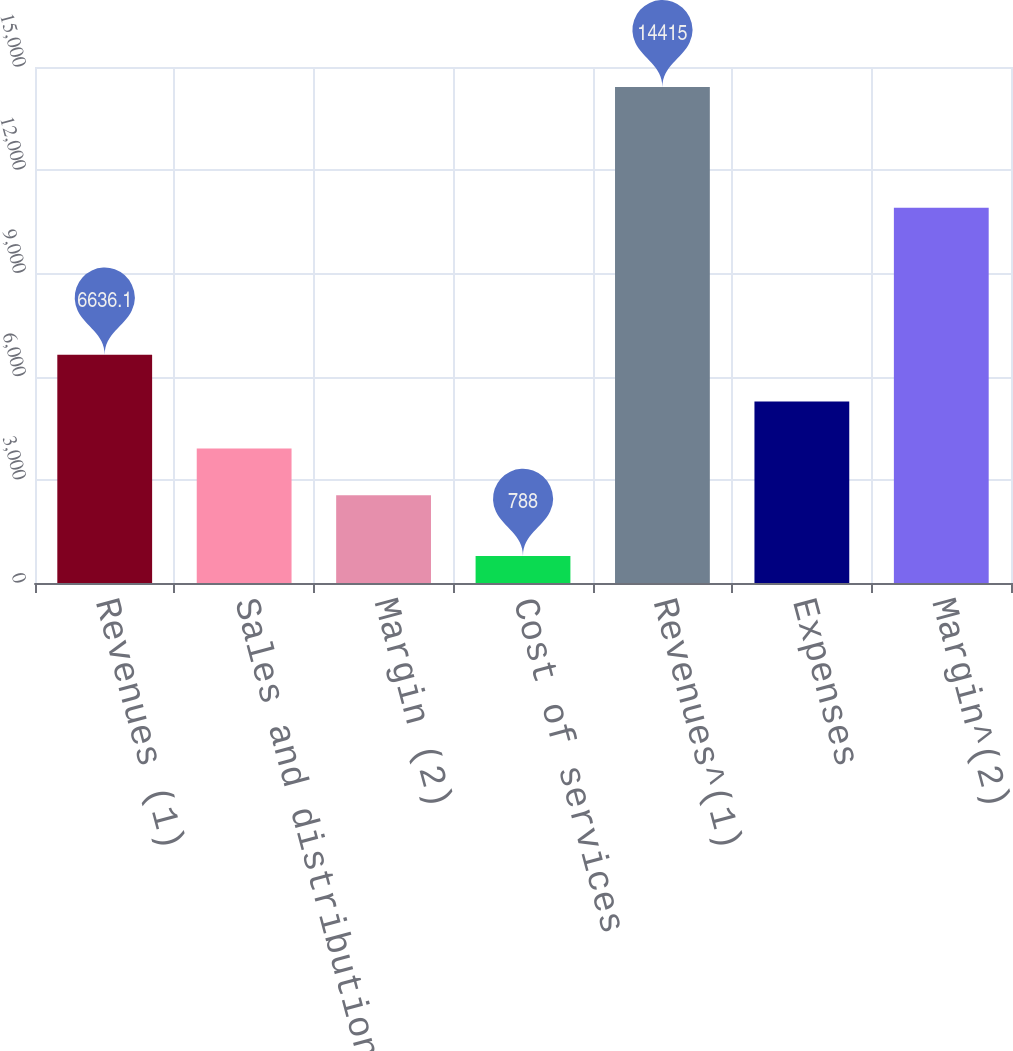Convert chart. <chart><loc_0><loc_0><loc_500><loc_500><bar_chart><fcel>Revenues (1)<fcel>Sales and distribution<fcel>Margin (2)<fcel>Cost of services<fcel>Revenues^(1)<fcel>Expenses<fcel>Margin^(2)<nl><fcel>6636.1<fcel>3910.7<fcel>2548<fcel>788<fcel>14415<fcel>5273.4<fcel>10909<nl></chart> 